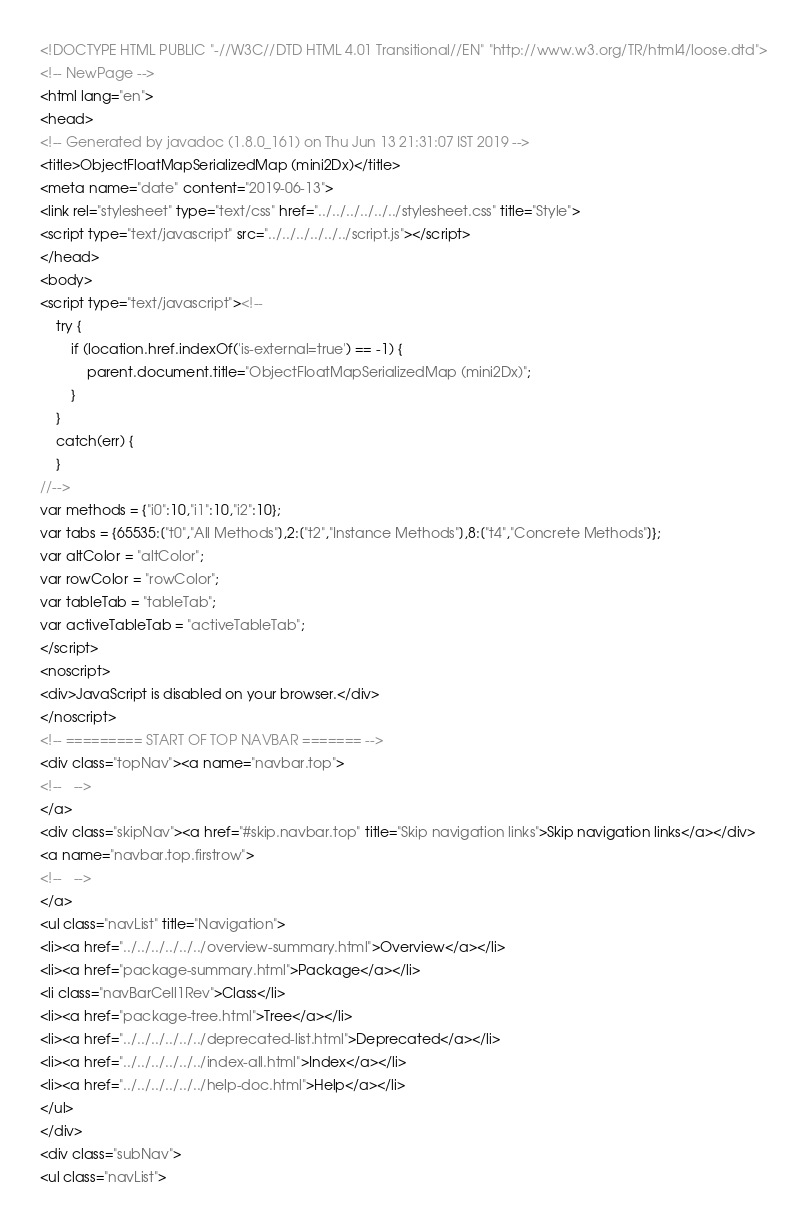Convert code to text. <code><loc_0><loc_0><loc_500><loc_500><_HTML_><!DOCTYPE HTML PUBLIC "-//W3C//DTD HTML 4.01 Transitional//EN" "http://www.w3.org/TR/html4/loose.dtd">
<!-- NewPage -->
<html lang="en">
<head>
<!-- Generated by javadoc (1.8.0_161) on Thu Jun 13 21:31:07 IST 2019 -->
<title>ObjectFloatMapSerializedMap (mini2Dx)</title>
<meta name="date" content="2019-06-13">
<link rel="stylesheet" type="text/css" href="../../../../../../stylesheet.css" title="Style">
<script type="text/javascript" src="../../../../../../script.js"></script>
</head>
<body>
<script type="text/javascript"><!--
    try {
        if (location.href.indexOf('is-external=true') == -1) {
            parent.document.title="ObjectFloatMapSerializedMap (mini2Dx)";
        }
    }
    catch(err) {
    }
//-->
var methods = {"i0":10,"i1":10,"i2":10};
var tabs = {65535:["t0","All Methods"],2:["t2","Instance Methods"],8:["t4","Concrete Methods"]};
var altColor = "altColor";
var rowColor = "rowColor";
var tableTab = "tableTab";
var activeTableTab = "activeTableTab";
</script>
<noscript>
<div>JavaScript is disabled on your browser.</div>
</noscript>
<!-- ========= START OF TOP NAVBAR ======= -->
<div class="topNav"><a name="navbar.top">
<!--   -->
</a>
<div class="skipNav"><a href="#skip.navbar.top" title="Skip navigation links">Skip navigation links</a></div>
<a name="navbar.top.firstrow">
<!--   -->
</a>
<ul class="navList" title="Navigation">
<li><a href="../../../../../../overview-summary.html">Overview</a></li>
<li><a href="package-summary.html">Package</a></li>
<li class="navBarCell1Rev">Class</li>
<li><a href="package-tree.html">Tree</a></li>
<li><a href="../../../../../../deprecated-list.html">Deprecated</a></li>
<li><a href="../../../../../../index-all.html">Index</a></li>
<li><a href="../../../../../../help-doc.html">Help</a></li>
</ul>
</div>
<div class="subNav">
<ul class="navList"></code> 